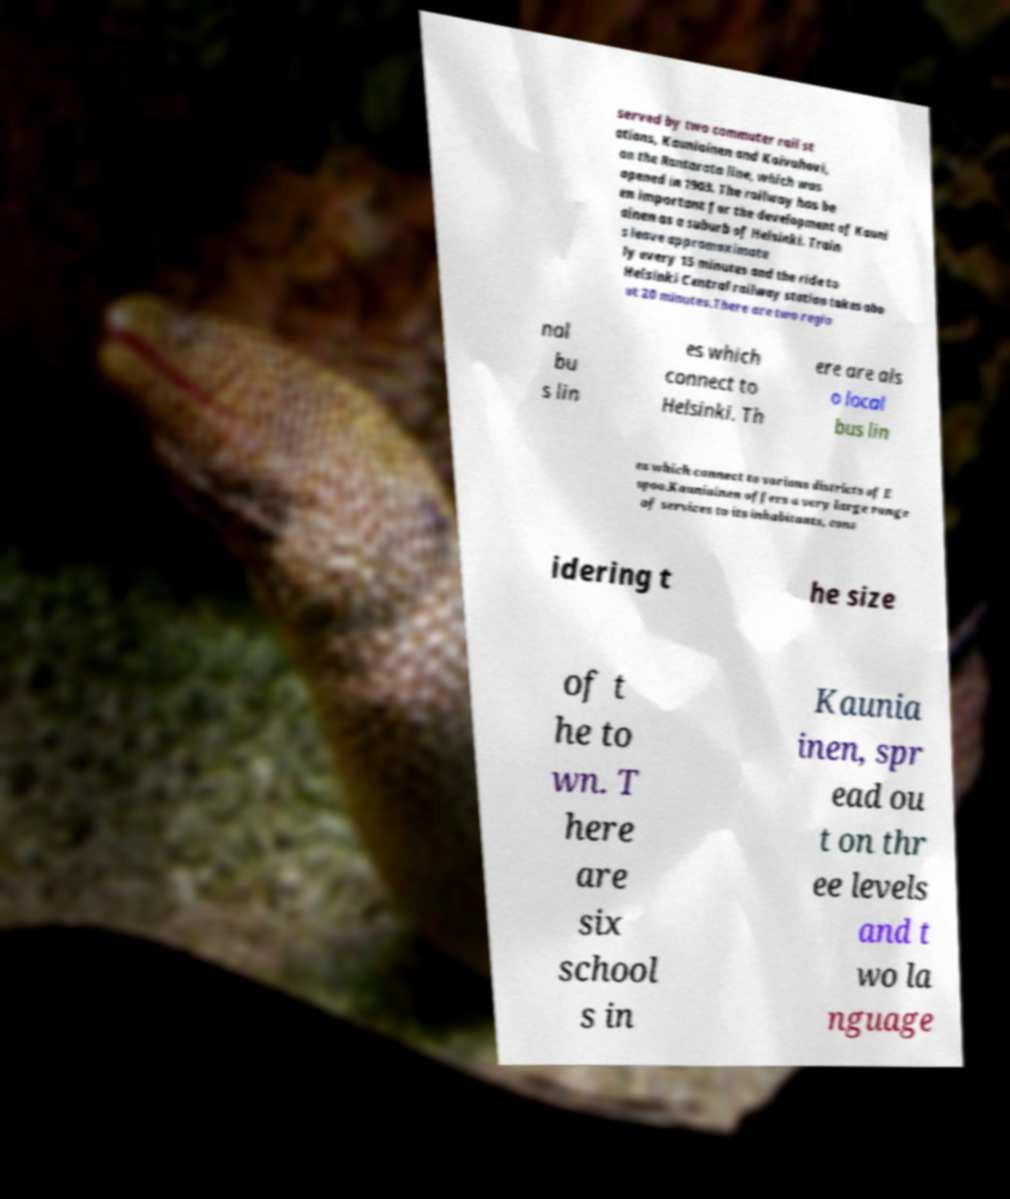I need the written content from this picture converted into text. Can you do that? served by two commuter rail st ations, Kauniainen and Koivuhovi, on the Rantarata line, which was opened in 1903. The railway has be en important for the development of Kauni ainen as a suburb of Helsinki. Train s leave appromaximate ly every 15 minutes and the ride to Helsinki Central railway station takes abo ut 20 minutes.There are two regio nal bu s lin es which connect to Helsinki. Th ere are als o local bus lin es which connect to various districts of E spoo.Kauniainen offers a very large range of services to its inhabitants, cons idering t he size of t he to wn. T here are six school s in Kaunia inen, spr ead ou t on thr ee levels and t wo la nguage 